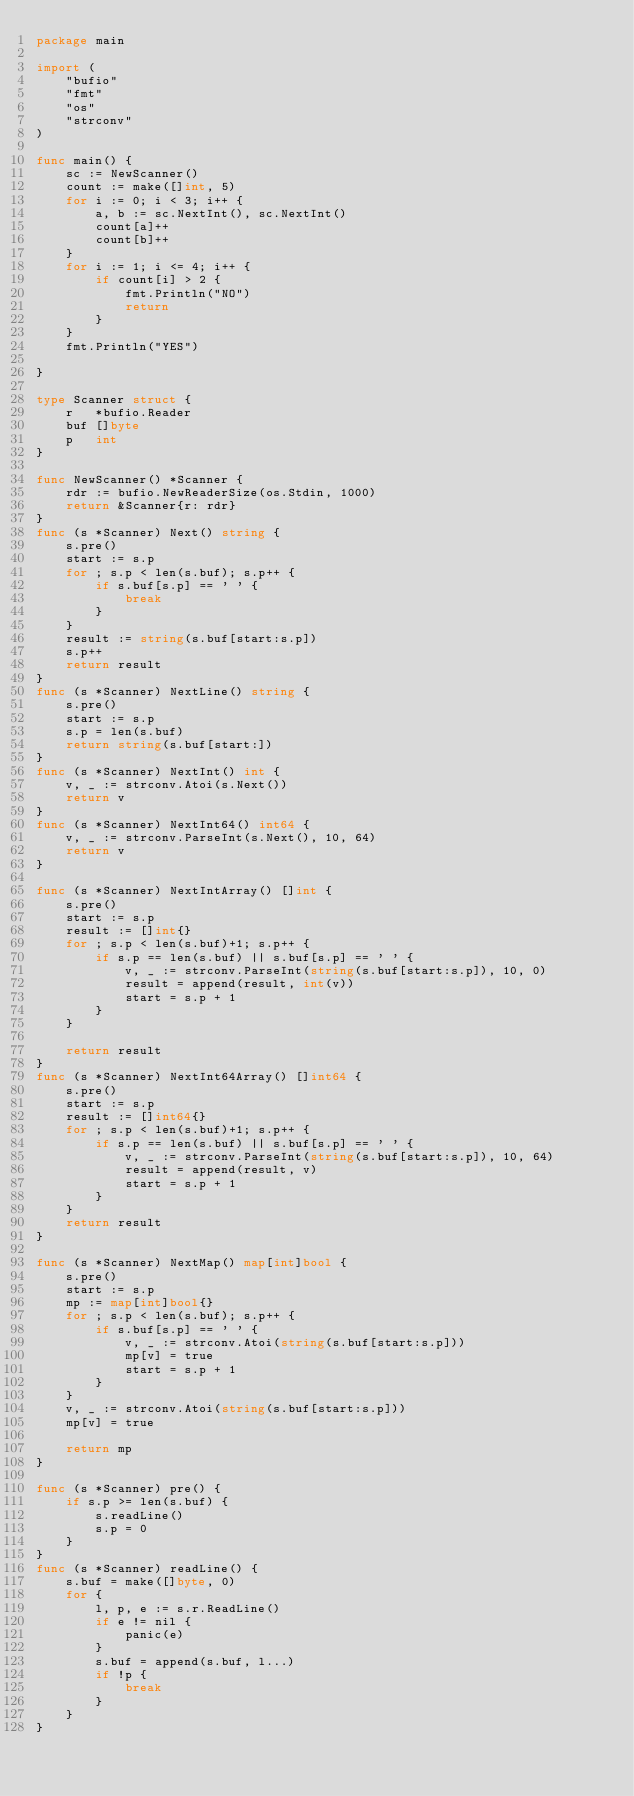Convert code to text. <code><loc_0><loc_0><loc_500><loc_500><_Go_>package main

import (
	"bufio"
	"fmt"
	"os"
	"strconv"
)

func main() {
	sc := NewScanner()
	count := make([]int, 5)
	for i := 0; i < 3; i++ {
		a, b := sc.NextInt(), sc.NextInt()
		count[a]++
		count[b]++
	}
	for i := 1; i <= 4; i++ {
		if count[i] > 2 {
			fmt.Println("NO")
			return
		}
	}
	fmt.Println("YES")

}

type Scanner struct {
	r   *bufio.Reader
	buf []byte
	p   int
}

func NewScanner() *Scanner {
	rdr := bufio.NewReaderSize(os.Stdin, 1000)
	return &Scanner{r: rdr}
}
func (s *Scanner) Next() string {
	s.pre()
	start := s.p
	for ; s.p < len(s.buf); s.p++ {
		if s.buf[s.p] == ' ' {
			break
		}
	}
	result := string(s.buf[start:s.p])
	s.p++
	return result
}
func (s *Scanner) NextLine() string {
	s.pre()
	start := s.p
	s.p = len(s.buf)
	return string(s.buf[start:])
}
func (s *Scanner) NextInt() int {
	v, _ := strconv.Atoi(s.Next())
	return v
}
func (s *Scanner) NextInt64() int64 {
	v, _ := strconv.ParseInt(s.Next(), 10, 64)
	return v
}

func (s *Scanner) NextIntArray() []int {
	s.pre()
	start := s.p
	result := []int{}
	for ; s.p < len(s.buf)+1; s.p++ {
		if s.p == len(s.buf) || s.buf[s.p] == ' ' {
			v, _ := strconv.ParseInt(string(s.buf[start:s.p]), 10, 0)
			result = append(result, int(v))
			start = s.p + 1
		}
	}

	return result
}
func (s *Scanner) NextInt64Array() []int64 {
	s.pre()
	start := s.p
	result := []int64{}
	for ; s.p < len(s.buf)+1; s.p++ {
		if s.p == len(s.buf) || s.buf[s.p] == ' ' {
			v, _ := strconv.ParseInt(string(s.buf[start:s.p]), 10, 64)
			result = append(result, v)
			start = s.p + 1
		}
	}
	return result
}

func (s *Scanner) NextMap() map[int]bool {
	s.pre()
	start := s.p
	mp := map[int]bool{}
	for ; s.p < len(s.buf); s.p++ {
		if s.buf[s.p] == ' ' {
			v, _ := strconv.Atoi(string(s.buf[start:s.p]))
			mp[v] = true
			start = s.p + 1
		}
	}
	v, _ := strconv.Atoi(string(s.buf[start:s.p]))
	mp[v] = true

	return mp
}

func (s *Scanner) pre() {
	if s.p >= len(s.buf) {
		s.readLine()
		s.p = 0
	}
}
func (s *Scanner) readLine() {
	s.buf = make([]byte, 0)
	for {
		l, p, e := s.r.ReadLine()
		if e != nil {
			panic(e)
		}
		s.buf = append(s.buf, l...)
		if !p {
			break
		}
	}
}
</code> 